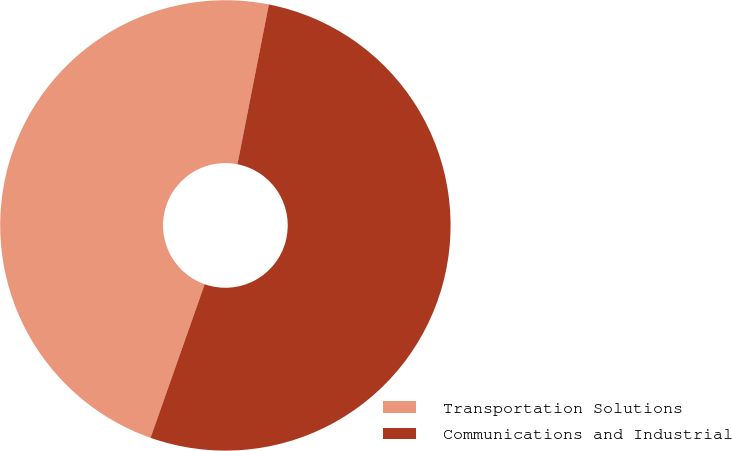Convert chart to OTSL. <chart><loc_0><loc_0><loc_500><loc_500><pie_chart><fcel>Transportation Solutions<fcel>Communications and Industrial<nl><fcel>47.7%<fcel>52.3%<nl></chart> 